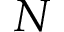<formula> <loc_0><loc_0><loc_500><loc_500>N</formula> 